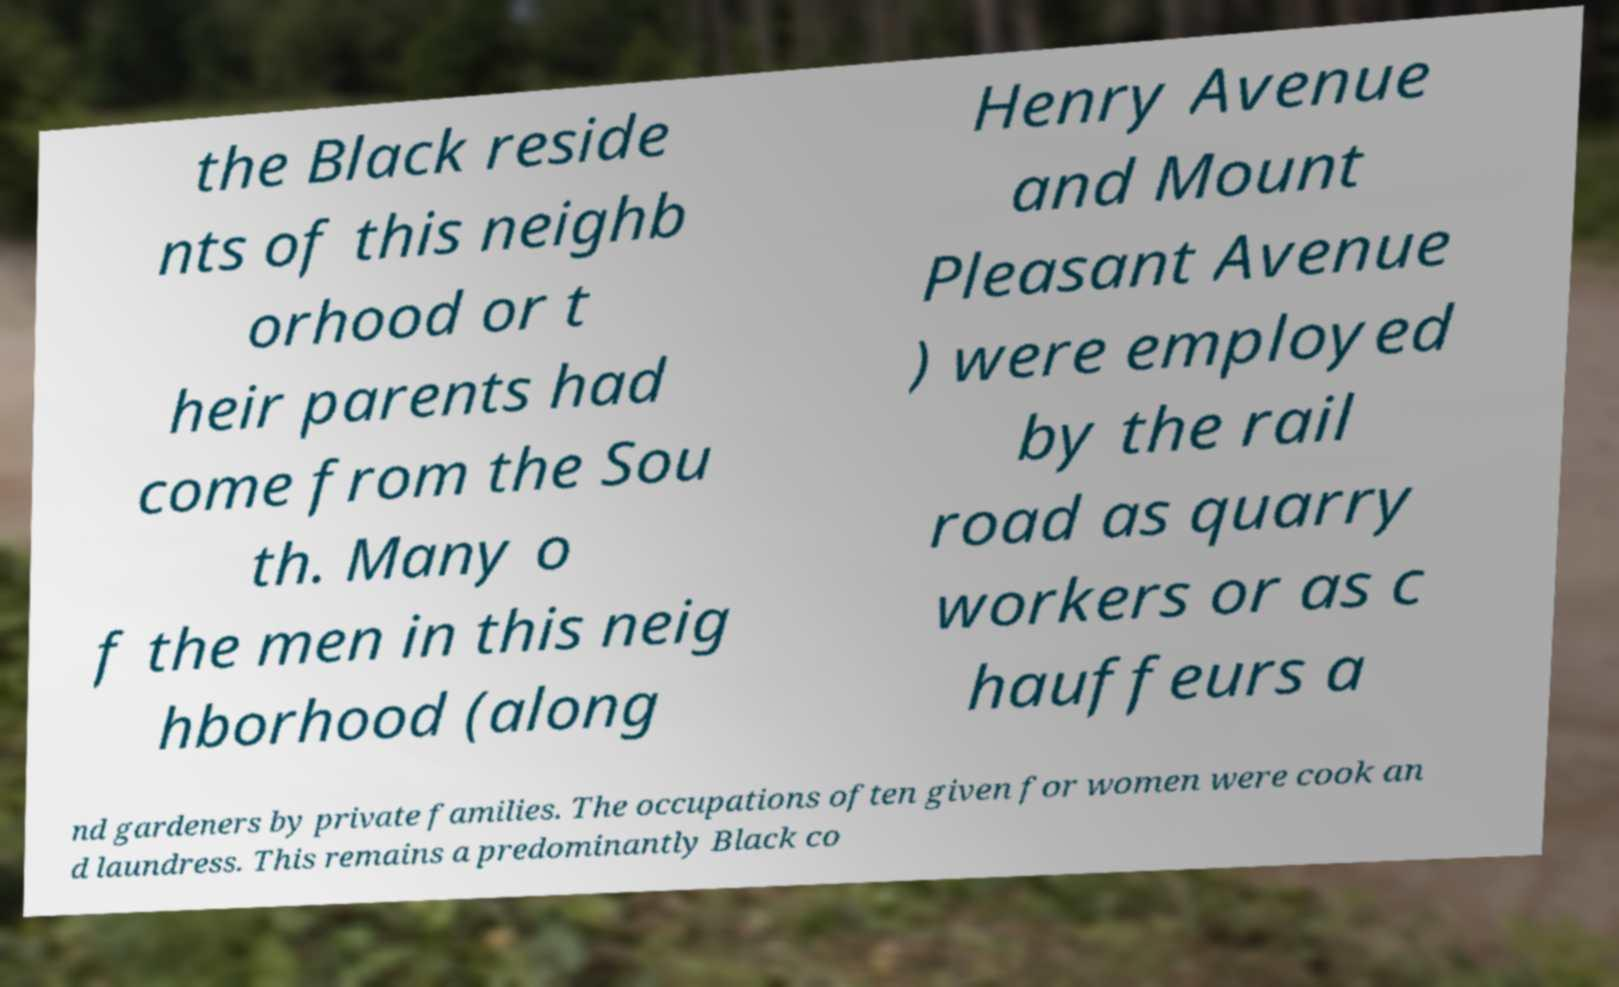Can you read and provide the text displayed in the image?This photo seems to have some interesting text. Can you extract and type it out for me? the Black reside nts of this neighb orhood or t heir parents had come from the Sou th. Many o f the men in this neig hborhood (along Henry Avenue and Mount Pleasant Avenue ) were employed by the rail road as quarry workers or as c hauffeurs a nd gardeners by private families. The occupations often given for women were cook an d laundress. This remains a predominantly Black co 